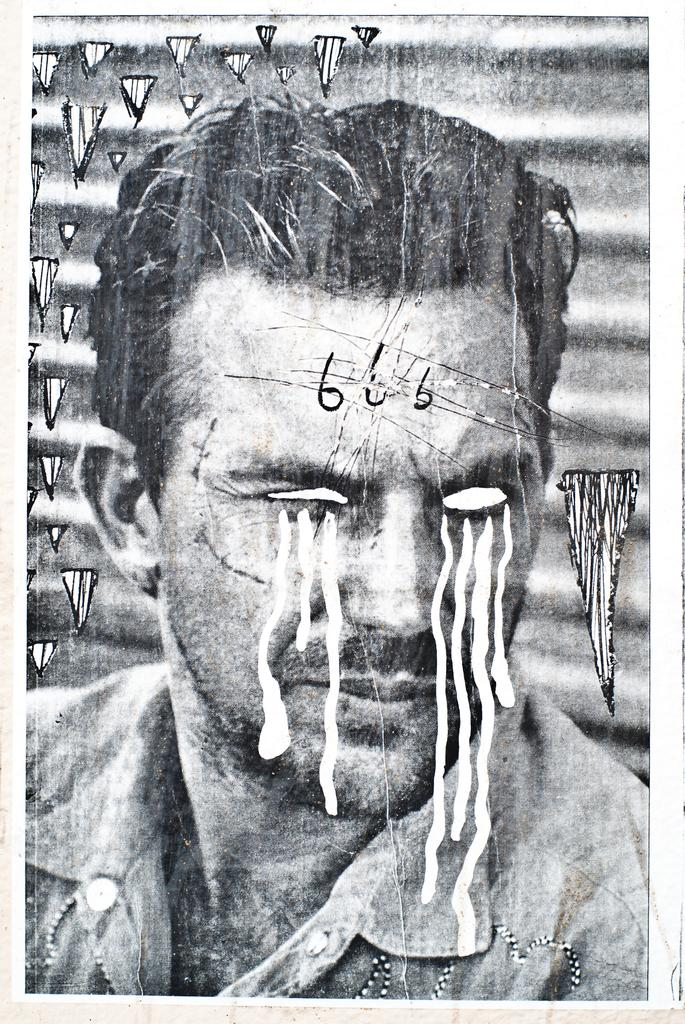What is the main subject of the image? The main subject of the image is a person's face. What is the color scheme of the image? The image is black and white. What else can be seen in the middle of the image besides the person's face? There are numbers in the middle of the image. How many clocks are visible in the image? There are no clocks present in the image. Can you describe the bite marks on the person's face in the image? There are no bite marks visible on the person's face in the image. 